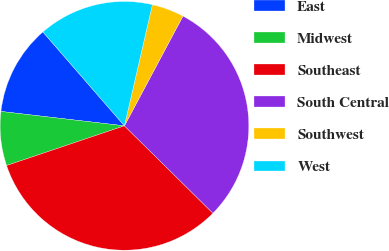<chart> <loc_0><loc_0><loc_500><loc_500><pie_chart><fcel>East<fcel>Midwest<fcel>Southeast<fcel>South Central<fcel>Southwest<fcel>West<nl><fcel>11.77%<fcel>7.02%<fcel>32.43%<fcel>29.6%<fcel>4.19%<fcel>14.99%<nl></chart> 